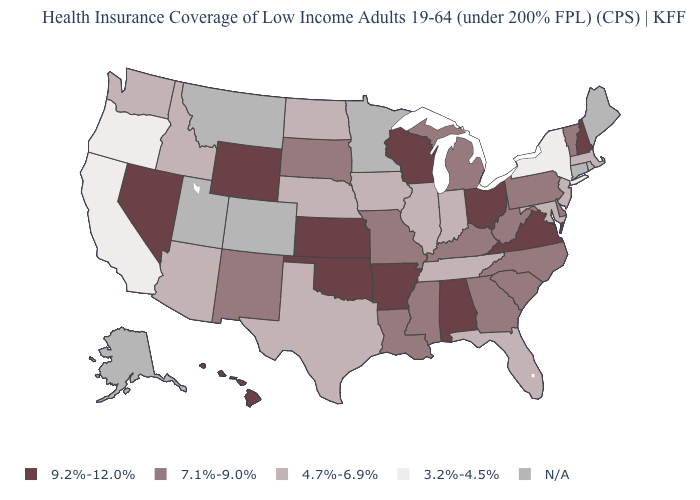Name the states that have a value in the range 7.1%-9.0%?
Short answer required. Delaware, Georgia, Kentucky, Louisiana, Michigan, Mississippi, Missouri, New Mexico, North Carolina, Pennsylvania, South Carolina, South Dakota, Vermont, West Virginia. Name the states that have a value in the range 3.2%-4.5%?
Concise answer only. California, New York, Oregon. Among the states that border Connecticut , does Massachusetts have the highest value?
Give a very brief answer. Yes. Does the first symbol in the legend represent the smallest category?
Concise answer only. No. What is the value of Illinois?
Concise answer only. 4.7%-6.9%. Is the legend a continuous bar?
Answer briefly. No. What is the value of West Virginia?
Be succinct. 7.1%-9.0%. Name the states that have a value in the range N/A?
Give a very brief answer. Alaska, Colorado, Connecticut, Maine, Minnesota, Montana, Rhode Island, Utah. Does California have the lowest value in the USA?
Write a very short answer. Yes. What is the value of Hawaii?
Give a very brief answer. 9.2%-12.0%. Among the states that border Vermont , which have the lowest value?
Answer briefly. New York. What is the value of Maryland?
Short answer required. 4.7%-6.9%. Does Florida have the highest value in the USA?
Answer briefly. No. What is the value of Kentucky?
Write a very short answer. 7.1%-9.0%. 